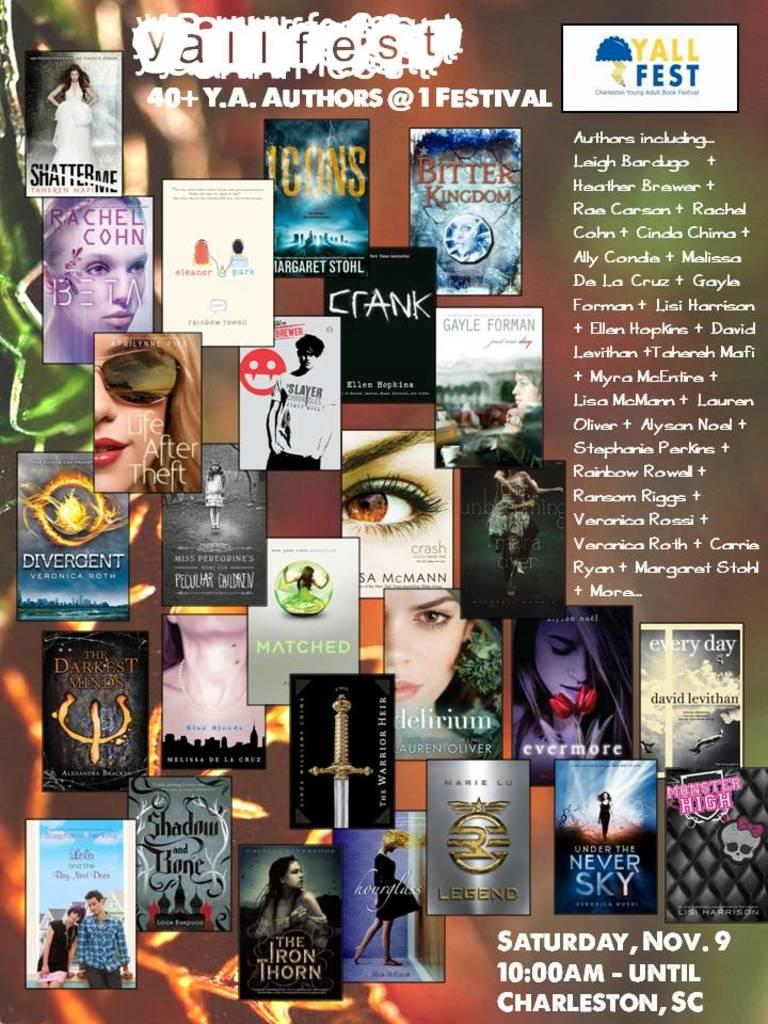<image>
Describe the image concisely. The yallfest Y.A. Authors festival was on Saturday, Nov. 9 in Charleston, SC. 